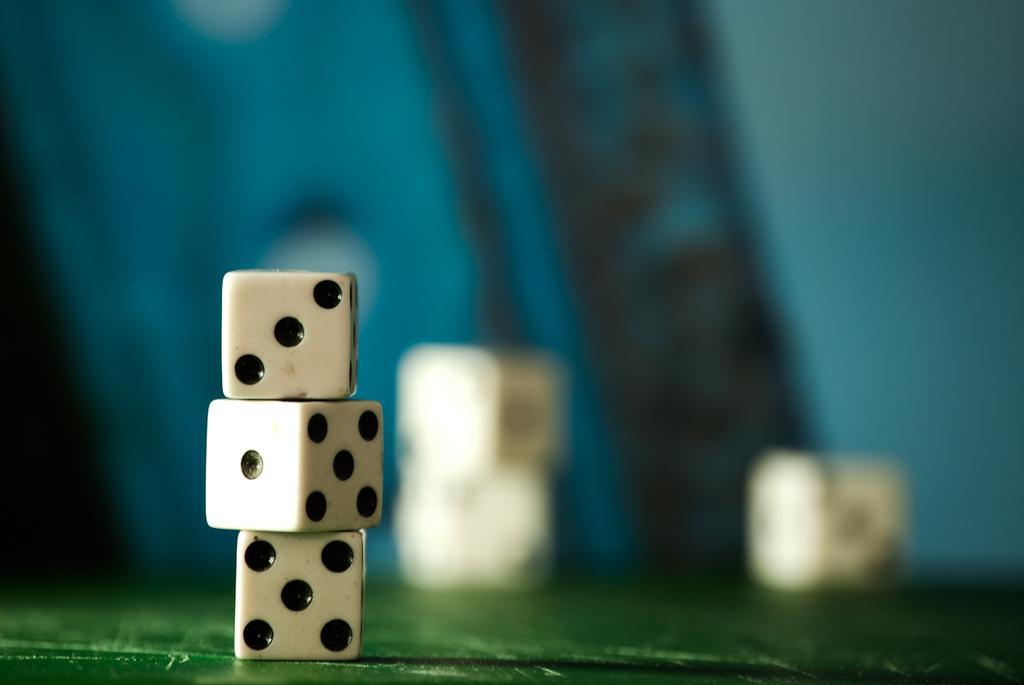Please provide a concise description of this image. In this picture we can see some cubes, behind we can see few more cubes. 